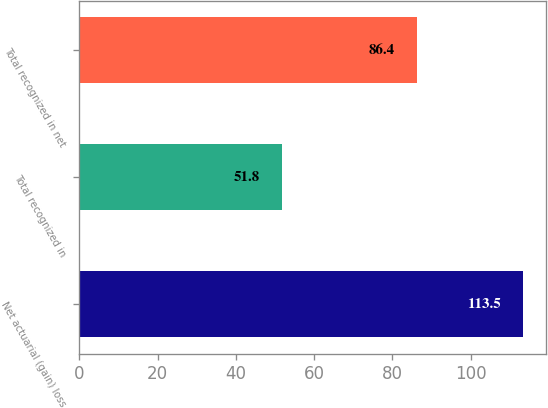Convert chart. <chart><loc_0><loc_0><loc_500><loc_500><bar_chart><fcel>Net actuarial (gain) loss<fcel>Total recognized in<fcel>Total recognized in net<nl><fcel>113.5<fcel>51.8<fcel>86.4<nl></chart> 